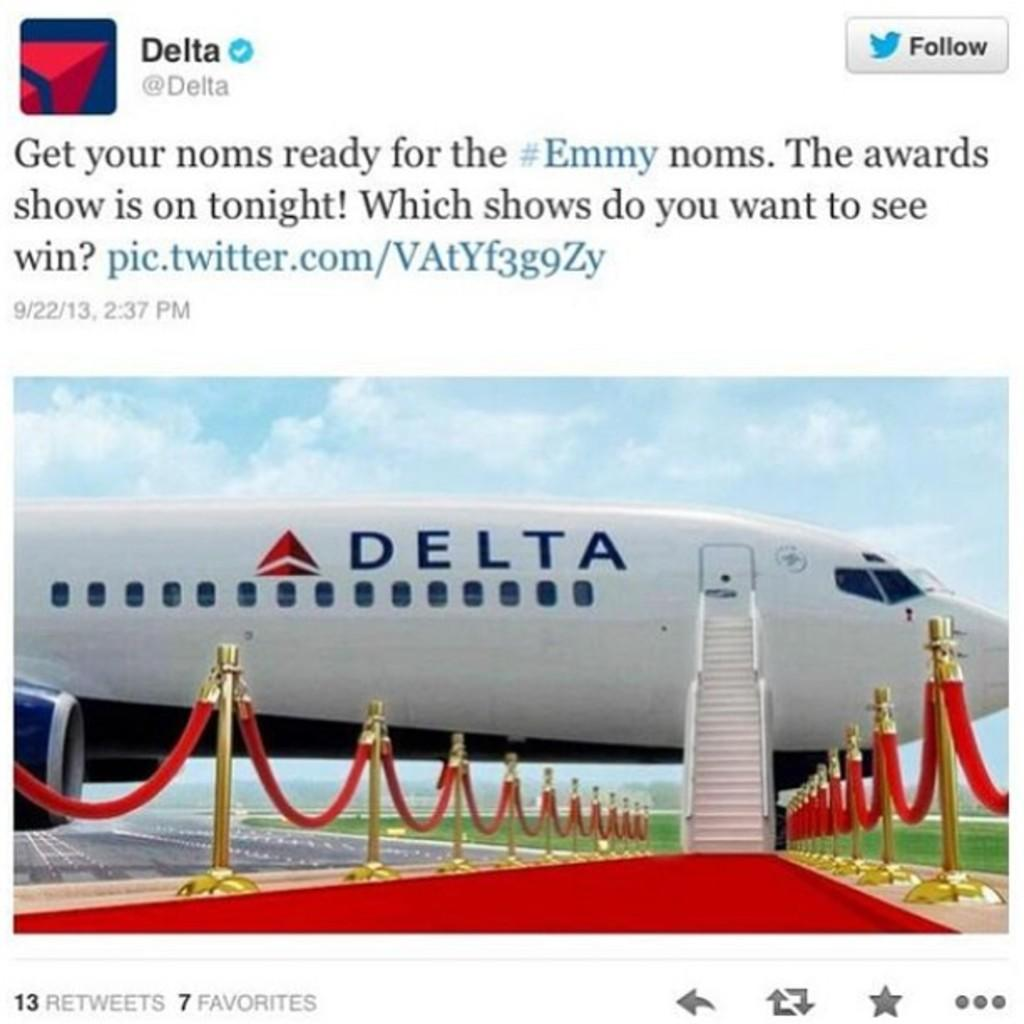<image>
Relay a brief, clear account of the picture shown. A Delta airlines plane has a red carpet laid out in front of it. 